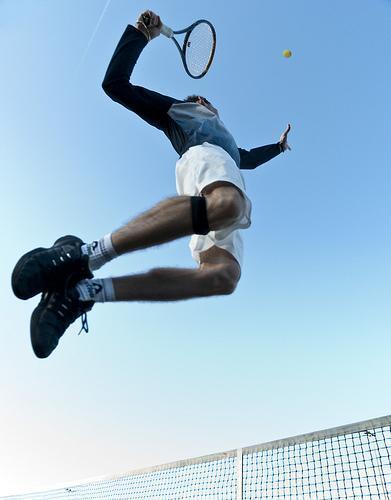How many of this man's legs have a black band?
Give a very brief answer. 1. How many people are wearing red?
Give a very brief answer. 0. 